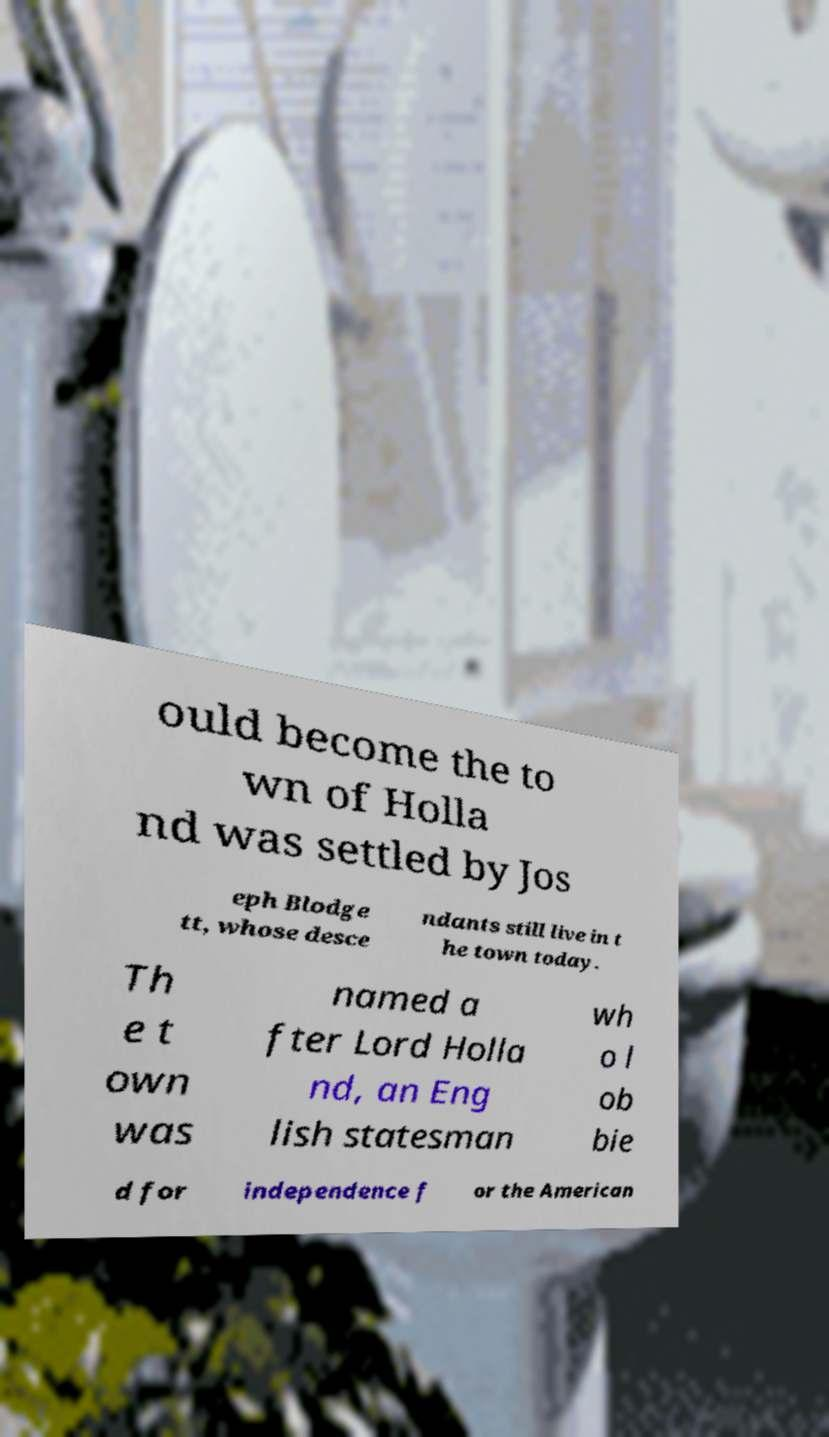I need the written content from this picture converted into text. Can you do that? ould become the to wn of Holla nd was settled by Jos eph Blodge tt, whose desce ndants still live in t he town today. Th e t own was named a fter Lord Holla nd, an Eng lish statesman wh o l ob bie d for independence f or the American 